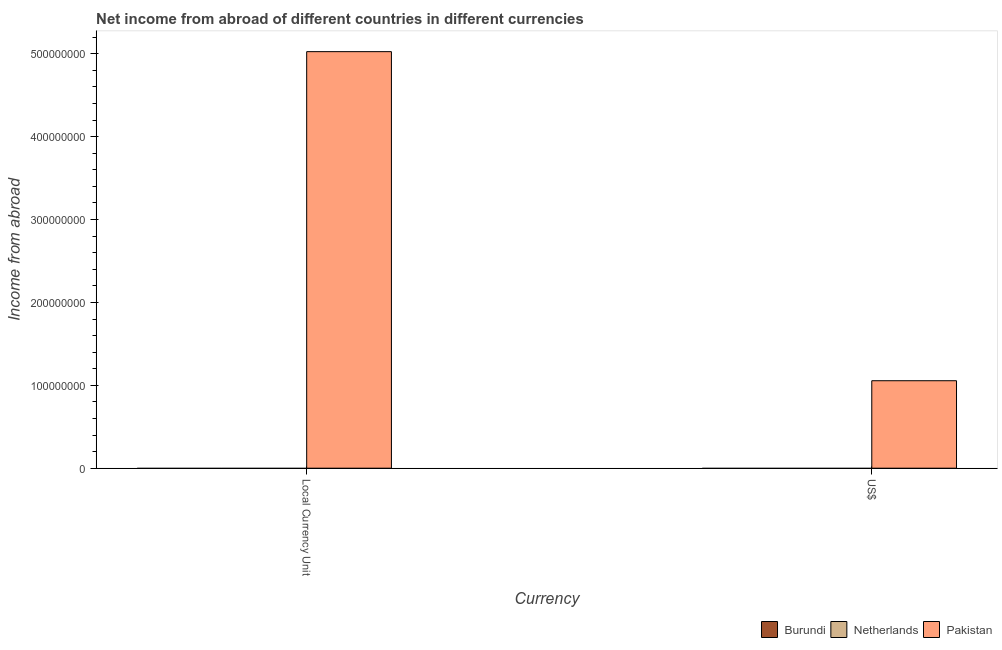How many different coloured bars are there?
Your answer should be very brief. 1. Are the number of bars on each tick of the X-axis equal?
Offer a terse response. Yes. How many bars are there on the 2nd tick from the left?
Offer a terse response. 1. How many bars are there on the 1st tick from the right?
Keep it short and to the point. 1. What is the label of the 2nd group of bars from the left?
Your answer should be very brief. US$. What is the income from abroad in constant 2005 us$ in Burundi?
Provide a succinct answer. 0. Across all countries, what is the maximum income from abroad in constant 2005 us$?
Ensure brevity in your answer.  5.03e+08. Across all countries, what is the minimum income from abroad in us$?
Your answer should be compact. 0. What is the total income from abroad in us$ in the graph?
Give a very brief answer. 1.06e+08. What is the difference between the income from abroad in constant 2005 us$ in Burundi and the income from abroad in us$ in Pakistan?
Give a very brief answer. -1.06e+08. What is the average income from abroad in constant 2005 us$ per country?
Ensure brevity in your answer.  1.68e+08. What is the difference between the income from abroad in us$ and income from abroad in constant 2005 us$ in Pakistan?
Provide a succinct answer. -3.97e+08. In how many countries, is the income from abroad in us$ greater than the average income from abroad in us$ taken over all countries?
Your response must be concise. 1. Are all the bars in the graph horizontal?
Your response must be concise. No. How many countries are there in the graph?
Ensure brevity in your answer.  3. Are the values on the major ticks of Y-axis written in scientific E-notation?
Make the answer very short. No. Does the graph contain grids?
Your answer should be compact. No. Where does the legend appear in the graph?
Offer a very short reply. Bottom right. How are the legend labels stacked?
Offer a terse response. Horizontal. What is the title of the graph?
Ensure brevity in your answer.  Net income from abroad of different countries in different currencies. Does "United States" appear as one of the legend labels in the graph?
Offer a terse response. No. What is the label or title of the X-axis?
Make the answer very short. Currency. What is the label or title of the Y-axis?
Provide a short and direct response. Income from abroad. What is the Income from abroad in Pakistan in Local Currency Unit?
Your answer should be very brief. 5.03e+08. What is the Income from abroad in Burundi in US$?
Your answer should be compact. 0. What is the Income from abroad in Netherlands in US$?
Your answer should be very brief. 0. What is the Income from abroad of Pakistan in US$?
Give a very brief answer. 1.06e+08. Across all Currency, what is the maximum Income from abroad of Pakistan?
Your answer should be very brief. 5.03e+08. Across all Currency, what is the minimum Income from abroad in Pakistan?
Provide a short and direct response. 1.06e+08. What is the total Income from abroad in Burundi in the graph?
Provide a succinct answer. 0. What is the total Income from abroad in Netherlands in the graph?
Provide a succinct answer. 0. What is the total Income from abroad in Pakistan in the graph?
Ensure brevity in your answer.  6.08e+08. What is the difference between the Income from abroad of Pakistan in Local Currency Unit and that in US$?
Provide a succinct answer. 3.97e+08. What is the average Income from abroad of Netherlands per Currency?
Make the answer very short. 0. What is the average Income from abroad of Pakistan per Currency?
Offer a very short reply. 3.04e+08. What is the ratio of the Income from abroad in Pakistan in Local Currency Unit to that in US$?
Give a very brief answer. 4.76. What is the difference between the highest and the second highest Income from abroad in Pakistan?
Provide a succinct answer. 3.97e+08. What is the difference between the highest and the lowest Income from abroad in Pakistan?
Offer a terse response. 3.97e+08. 